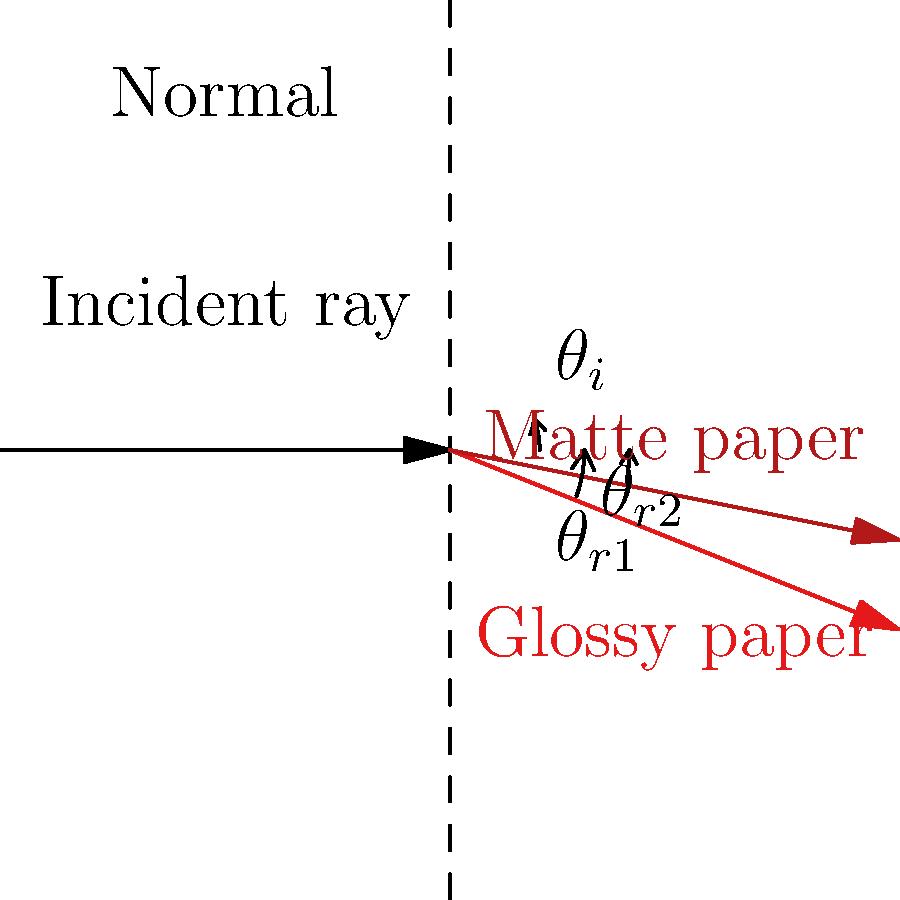In your print shop, you notice that colors appear differently on glossy and matte papers. Considering the refraction of light, explain why the perceived color intensity might be higher on glossy paper compared to matte paper. Use the diagram to support your answer, paying attention to the angles $\theta_i$, $\theta_{r1}$, and $\theta_{r2}$. To understand why colors appear more intense on glossy paper compared to matte paper, we need to consider the following steps:

1. Refraction: When light passes from air into paper, it refracts (bends) according to Snell's law: $n_1 \sin(\theta_i) = n_2 \sin(\theta_r)$, where $n_1$ and $n_2$ are the refractive indices of air and paper, respectively.

2. Surface characteristics:
   a) Glossy paper has a smooth surface, causing more specular reflection.
   b) Matte paper has a rougher surface, leading to more diffuse reflection.

3. Angle of refraction:
   a) For glossy paper (represented by $\theta_{r1}$), the angle of refraction is smaller.
   b) For matte paper (represented by $\theta_{r2}$), the angle of refraction is larger due to surface irregularities.

4. Light penetration:
   a) In glossy paper, light penetrates less deeply due to the smaller refraction angle.
   b) In matte paper, light penetrates more deeply due to the larger refraction angle.

5. Color perception:
   a) For glossy paper, more light is reflected directly to the viewer's eyes, resulting in more intense color perception.
   b) For matte paper, light is scattered more within the paper before being reflected, leading to a softer, less intense color appearance.

6. Concentration of reflected light:
   a) Glossy paper concentrates the reflected light, enhancing color intensity.
   b) Matte paper disperses the reflected light, reducing perceived color intensity.

The diagram illustrates these differences, showing how the refracted light paths differ between glossy and matte papers, directly impacting color perception and intensity.
Answer: Glossy paper reflects more light directly to the viewer's eyes due to its smooth surface and smaller refraction angle, concentrating the reflected light and resulting in more intense color perception compared to matte paper. 